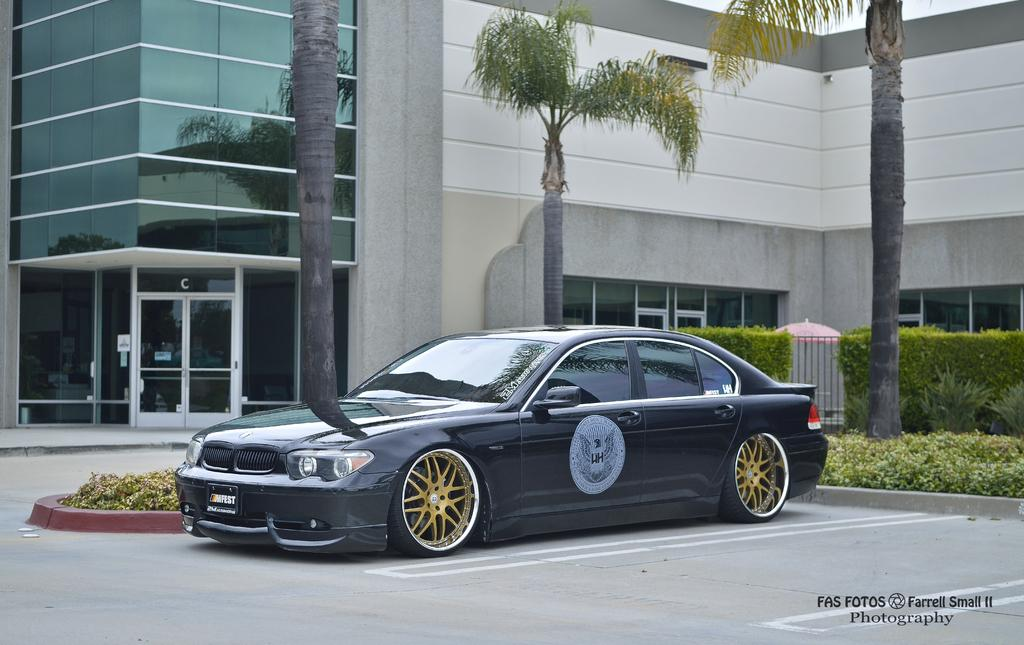What is the main subject in the center of the image? There is a car in the center of the image. What can be seen in the background of the image? There are buildings, trees, plants, and grass in the background of the image. What is at the bottom of the image? There is a road at the bottom of the image. How many pizzas are on the roof of the car in the image? There are no pizzas present in the image, and they are not on the roof of the car. Can you tell me who the owner of the car is in the image? There is no information about the car's owner in the image. 